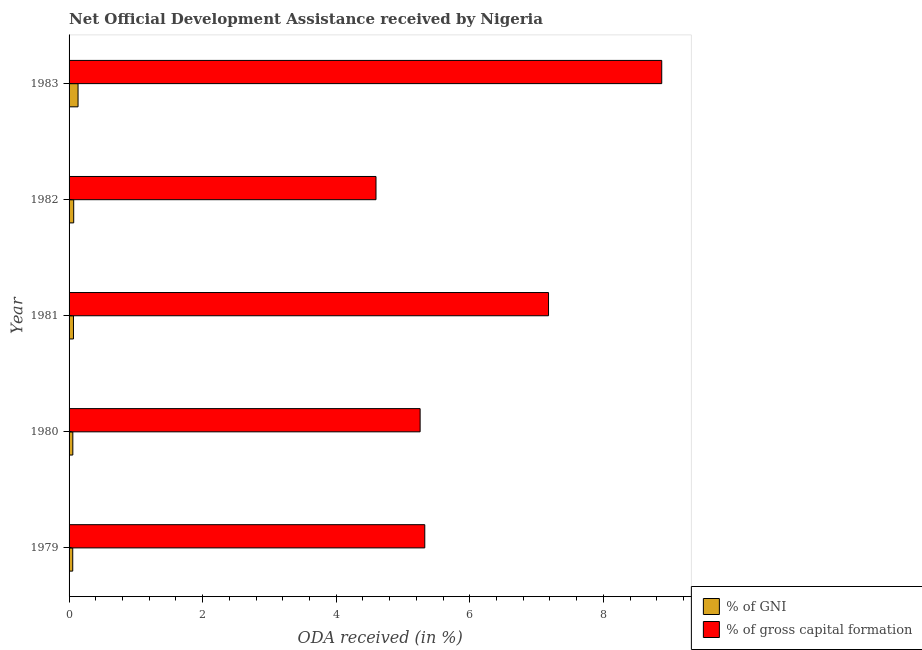What is the label of the 5th group of bars from the top?
Offer a terse response. 1979. What is the oda received as percentage of gross capital formation in 1980?
Your response must be concise. 5.26. Across all years, what is the maximum oda received as percentage of gni?
Provide a succinct answer. 0.13. Across all years, what is the minimum oda received as percentage of gni?
Provide a succinct answer. 0.05. In which year was the oda received as percentage of gni maximum?
Make the answer very short. 1983. In which year was the oda received as percentage of gni minimum?
Make the answer very short. 1979. What is the total oda received as percentage of gni in the graph?
Your answer should be compact. 0.38. What is the difference between the oda received as percentage of gross capital formation in 1980 and that in 1981?
Keep it short and to the point. -1.92. What is the difference between the oda received as percentage of gross capital formation in 1980 and the oda received as percentage of gni in 1983?
Make the answer very short. 5.12. What is the average oda received as percentage of gross capital formation per year?
Offer a very short reply. 6.25. In the year 1979, what is the difference between the oda received as percentage of gross capital formation and oda received as percentage of gni?
Offer a very short reply. 5.27. What is the difference between the highest and the second highest oda received as percentage of gross capital formation?
Provide a short and direct response. 1.7. What is the difference between the highest and the lowest oda received as percentage of gross capital formation?
Offer a terse response. 4.28. What does the 1st bar from the top in 1979 represents?
Your answer should be compact. % of gross capital formation. What does the 2nd bar from the bottom in 1979 represents?
Your response must be concise. % of gross capital formation. How many years are there in the graph?
Give a very brief answer. 5. What is the difference between two consecutive major ticks on the X-axis?
Your answer should be compact. 2. Are the values on the major ticks of X-axis written in scientific E-notation?
Your answer should be very brief. No. How many legend labels are there?
Your answer should be very brief. 2. How are the legend labels stacked?
Ensure brevity in your answer.  Vertical. What is the title of the graph?
Provide a succinct answer. Net Official Development Assistance received by Nigeria. What is the label or title of the X-axis?
Your answer should be very brief. ODA received (in %). What is the ODA received (in %) of % of GNI in 1979?
Provide a short and direct response. 0.05. What is the ODA received (in %) in % of gross capital formation in 1979?
Your answer should be compact. 5.33. What is the ODA received (in %) of % of GNI in 1980?
Ensure brevity in your answer.  0.06. What is the ODA received (in %) in % of gross capital formation in 1980?
Provide a succinct answer. 5.26. What is the ODA received (in %) in % of GNI in 1981?
Offer a terse response. 0.07. What is the ODA received (in %) of % of gross capital formation in 1981?
Your answer should be compact. 7.18. What is the ODA received (in %) in % of GNI in 1982?
Provide a short and direct response. 0.07. What is the ODA received (in %) of % of gross capital formation in 1982?
Ensure brevity in your answer.  4.6. What is the ODA received (in %) of % of GNI in 1983?
Provide a short and direct response. 0.13. What is the ODA received (in %) of % of gross capital formation in 1983?
Give a very brief answer. 8.87. Across all years, what is the maximum ODA received (in %) in % of GNI?
Offer a terse response. 0.13. Across all years, what is the maximum ODA received (in %) of % of gross capital formation?
Provide a short and direct response. 8.87. Across all years, what is the minimum ODA received (in %) in % of GNI?
Provide a succinct answer. 0.05. Across all years, what is the minimum ODA received (in %) of % of gross capital formation?
Give a very brief answer. 4.6. What is the total ODA received (in %) of % of GNI in the graph?
Your answer should be very brief. 0.38. What is the total ODA received (in %) in % of gross capital formation in the graph?
Provide a succinct answer. 31.23. What is the difference between the ODA received (in %) in % of GNI in 1979 and that in 1980?
Keep it short and to the point. -0. What is the difference between the ODA received (in %) of % of gross capital formation in 1979 and that in 1980?
Keep it short and to the point. 0.07. What is the difference between the ODA received (in %) in % of GNI in 1979 and that in 1981?
Ensure brevity in your answer.  -0.01. What is the difference between the ODA received (in %) of % of gross capital formation in 1979 and that in 1981?
Offer a very short reply. -1.85. What is the difference between the ODA received (in %) in % of GNI in 1979 and that in 1982?
Make the answer very short. -0.01. What is the difference between the ODA received (in %) of % of gross capital formation in 1979 and that in 1982?
Your answer should be very brief. 0.73. What is the difference between the ODA received (in %) in % of GNI in 1979 and that in 1983?
Your response must be concise. -0.08. What is the difference between the ODA received (in %) of % of gross capital formation in 1979 and that in 1983?
Offer a very short reply. -3.55. What is the difference between the ODA received (in %) of % of GNI in 1980 and that in 1981?
Your answer should be very brief. -0.01. What is the difference between the ODA received (in %) of % of gross capital formation in 1980 and that in 1981?
Provide a succinct answer. -1.92. What is the difference between the ODA received (in %) of % of GNI in 1980 and that in 1982?
Provide a short and direct response. -0.01. What is the difference between the ODA received (in %) in % of gross capital formation in 1980 and that in 1982?
Ensure brevity in your answer.  0.66. What is the difference between the ODA received (in %) in % of GNI in 1980 and that in 1983?
Offer a very short reply. -0.08. What is the difference between the ODA received (in %) in % of gross capital formation in 1980 and that in 1983?
Make the answer very short. -3.62. What is the difference between the ODA received (in %) in % of GNI in 1981 and that in 1982?
Provide a short and direct response. -0. What is the difference between the ODA received (in %) in % of gross capital formation in 1981 and that in 1982?
Ensure brevity in your answer.  2.58. What is the difference between the ODA received (in %) of % of GNI in 1981 and that in 1983?
Provide a succinct answer. -0.07. What is the difference between the ODA received (in %) in % of gross capital formation in 1981 and that in 1983?
Offer a very short reply. -1.7. What is the difference between the ODA received (in %) in % of GNI in 1982 and that in 1983?
Make the answer very short. -0.07. What is the difference between the ODA received (in %) of % of gross capital formation in 1982 and that in 1983?
Your answer should be very brief. -4.28. What is the difference between the ODA received (in %) in % of GNI in 1979 and the ODA received (in %) in % of gross capital formation in 1980?
Your response must be concise. -5.2. What is the difference between the ODA received (in %) in % of GNI in 1979 and the ODA received (in %) in % of gross capital formation in 1981?
Your response must be concise. -7.12. What is the difference between the ODA received (in %) of % of GNI in 1979 and the ODA received (in %) of % of gross capital formation in 1982?
Make the answer very short. -4.54. What is the difference between the ODA received (in %) of % of GNI in 1979 and the ODA received (in %) of % of gross capital formation in 1983?
Offer a terse response. -8.82. What is the difference between the ODA received (in %) of % of GNI in 1980 and the ODA received (in %) of % of gross capital formation in 1981?
Provide a short and direct response. -7.12. What is the difference between the ODA received (in %) of % of GNI in 1980 and the ODA received (in %) of % of gross capital formation in 1982?
Your answer should be very brief. -4.54. What is the difference between the ODA received (in %) in % of GNI in 1980 and the ODA received (in %) in % of gross capital formation in 1983?
Your response must be concise. -8.82. What is the difference between the ODA received (in %) of % of GNI in 1981 and the ODA received (in %) of % of gross capital formation in 1982?
Keep it short and to the point. -4.53. What is the difference between the ODA received (in %) of % of GNI in 1981 and the ODA received (in %) of % of gross capital formation in 1983?
Give a very brief answer. -8.81. What is the difference between the ODA received (in %) of % of GNI in 1982 and the ODA received (in %) of % of gross capital formation in 1983?
Your answer should be very brief. -8.8. What is the average ODA received (in %) of % of GNI per year?
Offer a terse response. 0.08. What is the average ODA received (in %) in % of gross capital formation per year?
Your answer should be compact. 6.25. In the year 1979, what is the difference between the ODA received (in %) in % of GNI and ODA received (in %) in % of gross capital formation?
Keep it short and to the point. -5.27. In the year 1980, what is the difference between the ODA received (in %) in % of GNI and ODA received (in %) in % of gross capital formation?
Provide a short and direct response. -5.2. In the year 1981, what is the difference between the ODA received (in %) of % of GNI and ODA received (in %) of % of gross capital formation?
Keep it short and to the point. -7.11. In the year 1982, what is the difference between the ODA received (in %) of % of GNI and ODA received (in %) of % of gross capital formation?
Keep it short and to the point. -4.53. In the year 1983, what is the difference between the ODA received (in %) in % of GNI and ODA received (in %) in % of gross capital formation?
Your response must be concise. -8.74. What is the ratio of the ODA received (in %) of % of GNI in 1979 to that in 1980?
Offer a very short reply. 0.97. What is the ratio of the ODA received (in %) of % of gross capital formation in 1979 to that in 1980?
Offer a very short reply. 1.01. What is the ratio of the ODA received (in %) in % of GNI in 1979 to that in 1981?
Make the answer very short. 0.83. What is the ratio of the ODA received (in %) of % of gross capital formation in 1979 to that in 1981?
Your answer should be very brief. 0.74. What is the ratio of the ODA received (in %) in % of GNI in 1979 to that in 1982?
Give a very brief answer. 0.79. What is the ratio of the ODA received (in %) of % of gross capital formation in 1979 to that in 1982?
Give a very brief answer. 1.16. What is the ratio of the ODA received (in %) of % of GNI in 1979 to that in 1983?
Provide a succinct answer. 0.41. What is the ratio of the ODA received (in %) of % of gross capital formation in 1979 to that in 1983?
Your response must be concise. 0.6. What is the ratio of the ODA received (in %) in % of GNI in 1980 to that in 1981?
Keep it short and to the point. 0.85. What is the ratio of the ODA received (in %) of % of gross capital formation in 1980 to that in 1981?
Your answer should be very brief. 0.73. What is the ratio of the ODA received (in %) of % of GNI in 1980 to that in 1982?
Provide a succinct answer. 0.81. What is the ratio of the ODA received (in %) in % of gross capital formation in 1980 to that in 1982?
Provide a succinct answer. 1.14. What is the ratio of the ODA received (in %) of % of GNI in 1980 to that in 1983?
Offer a terse response. 0.42. What is the ratio of the ODA received (in %) of % of gross capital formation in 1980 to that in 1983?
Your answer should be compact. 0.59. What is the ratio of the ODA received (in %) of % of GNI in 1981 to that in 1982?
Your answer should be very brief. 0.95. What is the ratio of the ODA received (in %) of % of gross capital formation in 1981 to that in 1982?
Your response must be concise. 1.56. What is the ratio of the ODA received (in %) in % of GNI in 1981 to that in 1983?
Give a very brief answer. 0.49. What is the ratio of the ODA received (in %) in % of gross capital formation in 1981 to that in 1983?
Offer a very short reply. 0.81. What is the ratio of the ODA received (in %) in % of GNI in 1982 to that in 1983?
Ensure brevity in your answer.  0.52. What is the ratio of the ODA received (in %) of % of gross capital formation in 1982 to that in 1983?
Offer a terse response. 0.52. What is the difference between the highest and the second highest ODA received (in %) in % of GNI?
Your answer should be compact. 0.07. What is the difference between the highest and the second highest ODA received (in %) of % of gross capital formation?
Ensure brevity in your answer.  1.7. What is the difference between the highest and the lowest ODA received (in %) in % of GNI?
Ensure brevity in your answer.  0.08. What is the difference between the highest and the lowest ODA received (in %) in % of gross capital formation?
Your answer should be compact. 4.28. 